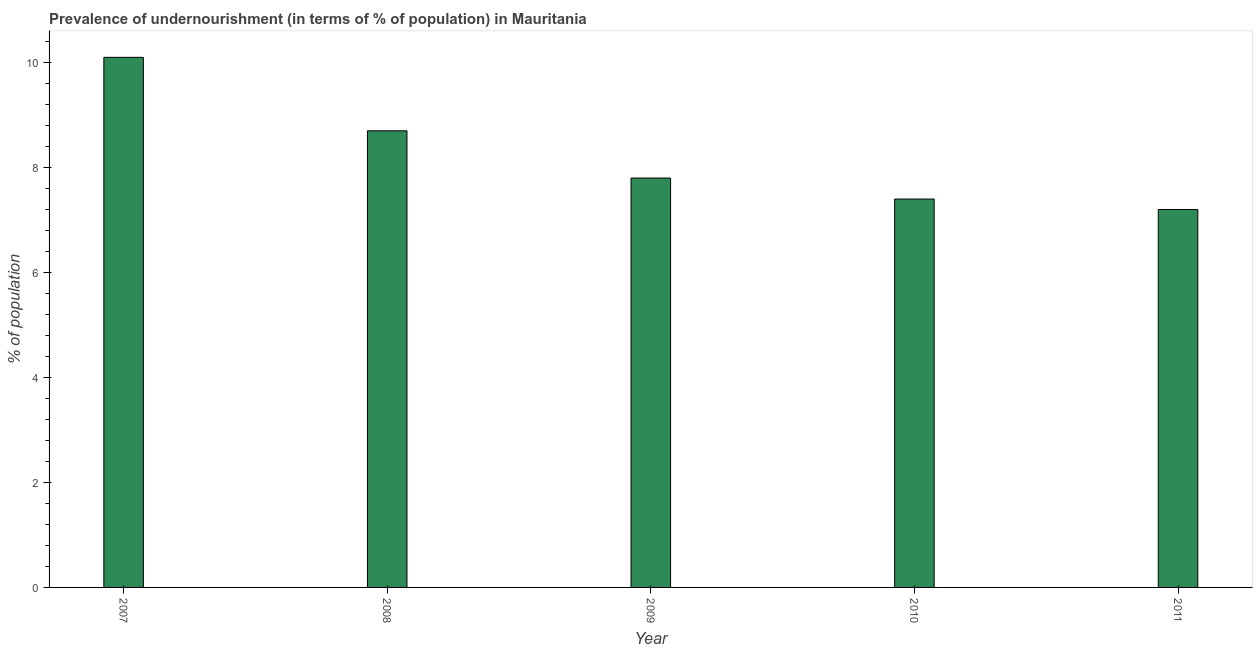Does the graph contain grids?
Ensure brevity in your answer.  No. What is the title of the graph?
Make the answer very short. Prevalence of undernourishment (in terms of % of population) in Mauritania. What is the label or title of the Y-axis?
Provide a succinct answer. % of population. Across all years, what is the minimum percentage of undernourished population?
Provide a succinct answer. 7.2. In which year was the percentage of undernourished population maximum?
Offer a very short reply. 2007. What is the sum of the percentage of undernourished population?
Provide a succinct answer. 41.2. What is the average percentage of undernourished population per year?
Make the answer very short. 8.24. What is the median percentage of undernourished population?
Provide a short and direct response. 7.8. In how many years, is the percentage of undernourished population greater than 0.4 %?
Keep it short and to the point. 5. Do a majority of the years between 2009 and 2010 (inclusive) have percentage of undernourished population greater than 4 %?
Provide a succinct answer. Yes. What is the ratio of the percentage of undernourished population in 2007 to that in 2008?
Your answer should be compact. 1.16. Is the percentage of undernourished population in 2010 less than that in 2011?
Keep it short and to the point. No. Is the difference between the percentage of undernourished population in 2008 and 2011 greater than the difference between any two years?
Give a very brief answer. No. What is the difference between the highest and the second highest percentage of undernourished population?
Your answer should be very brief. 1.4. Are all the bars in the graph horizontal?
Provide a succinct answer. No. What is the % of population in 2007?
Offer a terse response. 10.1. What is the difference between the % of population in 2007 and 2008?
Make the answer very short. 1.4. What is the difference between the % of population in 2007 and 2009?
Provide a succinct answer. 2.3. What is the difference between the % of population in 2007 and 2010?
Your answer should be very brief. 2.7. What is the difference between the % of population in 2007 and 2011?
Offer a terse response. 2.9. What is the difference between the % of population in 2008 and 2009?
Ensure brevity in your answer.  0.9. What is the difference between the % of population in 2008 and 2010?
Ensure brevity in your answer.  1.3. What is the difference between the % of population in 2009 and 2010?
Ensure brevity in your answer.  0.4. What is the ratio of the % of population in 2007 to that in 2008?
Your response must be concise. 1.16. What is the ratio of the % of population in 2007 to that in 2009?
Provide a succinct answer. 1.29. What is the ratio of the % of population in 2007 to that in 2010?
Make the answer very short. 1.36. What is the ratio of the % of population in 2007 to that in 2011?
Offer a terse response. 1.4. What is the ratio of the % of population in 2008 to that in 2009?
Offer a terse response. 1.11. What is the ratio of the % of population in 2008 to that in 2010?
Keep it short and to the point. 1.18. What is the ratio of the % of population in 2008 to that in 2011?
Your response must be concise. 1.21. What is the ratio of the % of population in 2009 to that in 2010?
Your answer should be compact. 1.05. What is the ratio of the % of population in 2009 to that in 2011?
Provide a short and direct response. 1.08. What is the ratio of the % of population in 2010 to that in 2011?
Offer a very short reply. 1.03. 